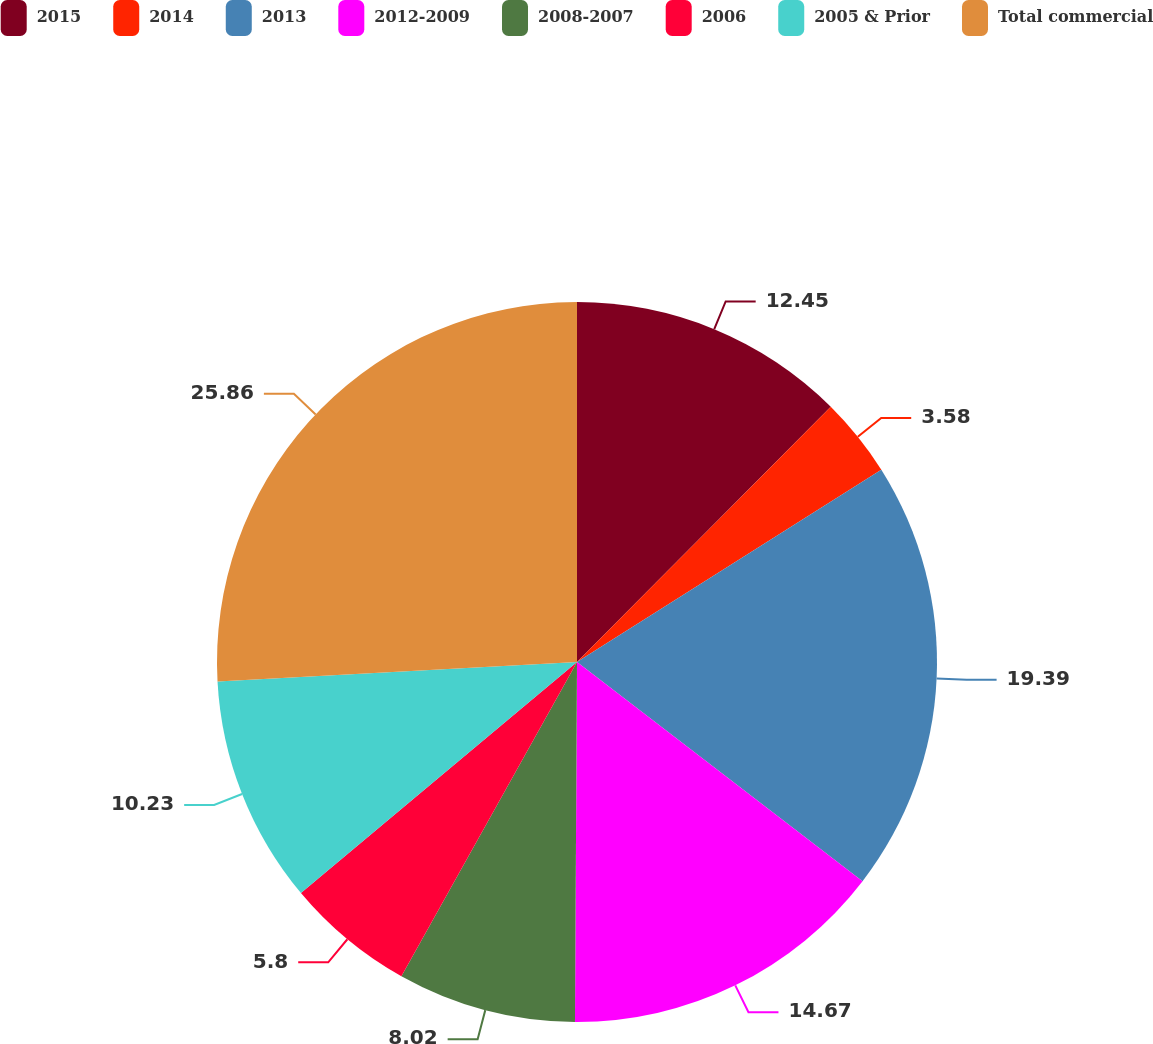Convert chart. <chart><loc_0><loc_0><loc_500><loc_500><pie_chart><fcel>2015<fcel>2014<fcel>2013<fcel>2012-2009<fcel>2008-2007<fcel>2006<fcel>2005 & Prior<fcel>Total commercial<nl><fcel>12.45%<fcel>3.58%<fcel>19.39%<fcel>14.67%<fcel>8.02%<fcel>5.8%<fcel>10.23%<fcel>25.86%<nl></chart> 